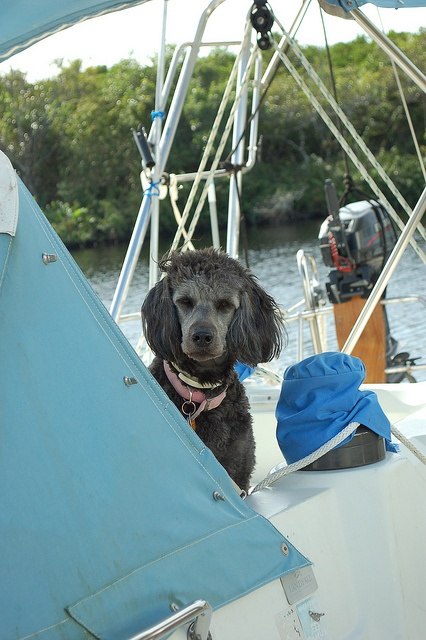Describe the objects in this image and their specific colors. I can see boat in lightblue, lightgray, gray, black, and darkgray tones and dog in darkgray, black, gray, and lightgray tones in this image. 